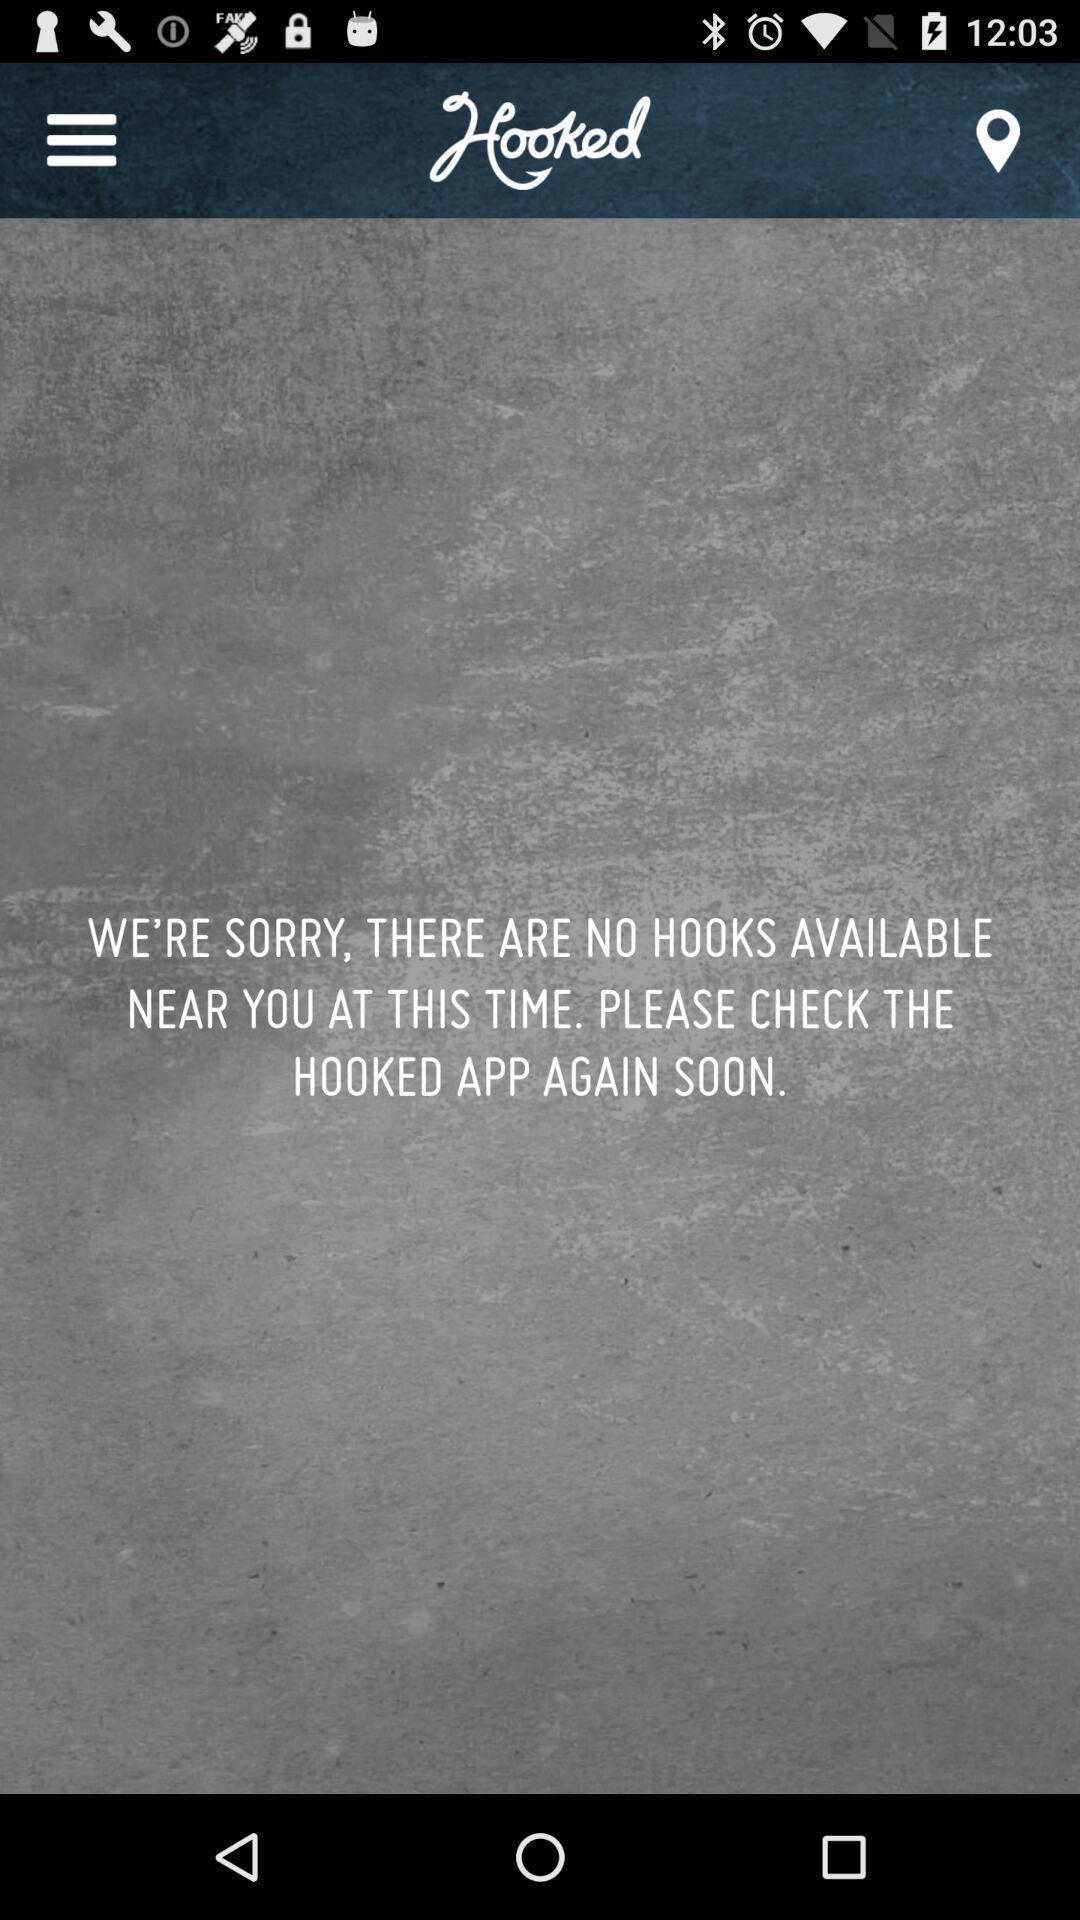Please provide a description for this image. Page displaying a sorry message. 